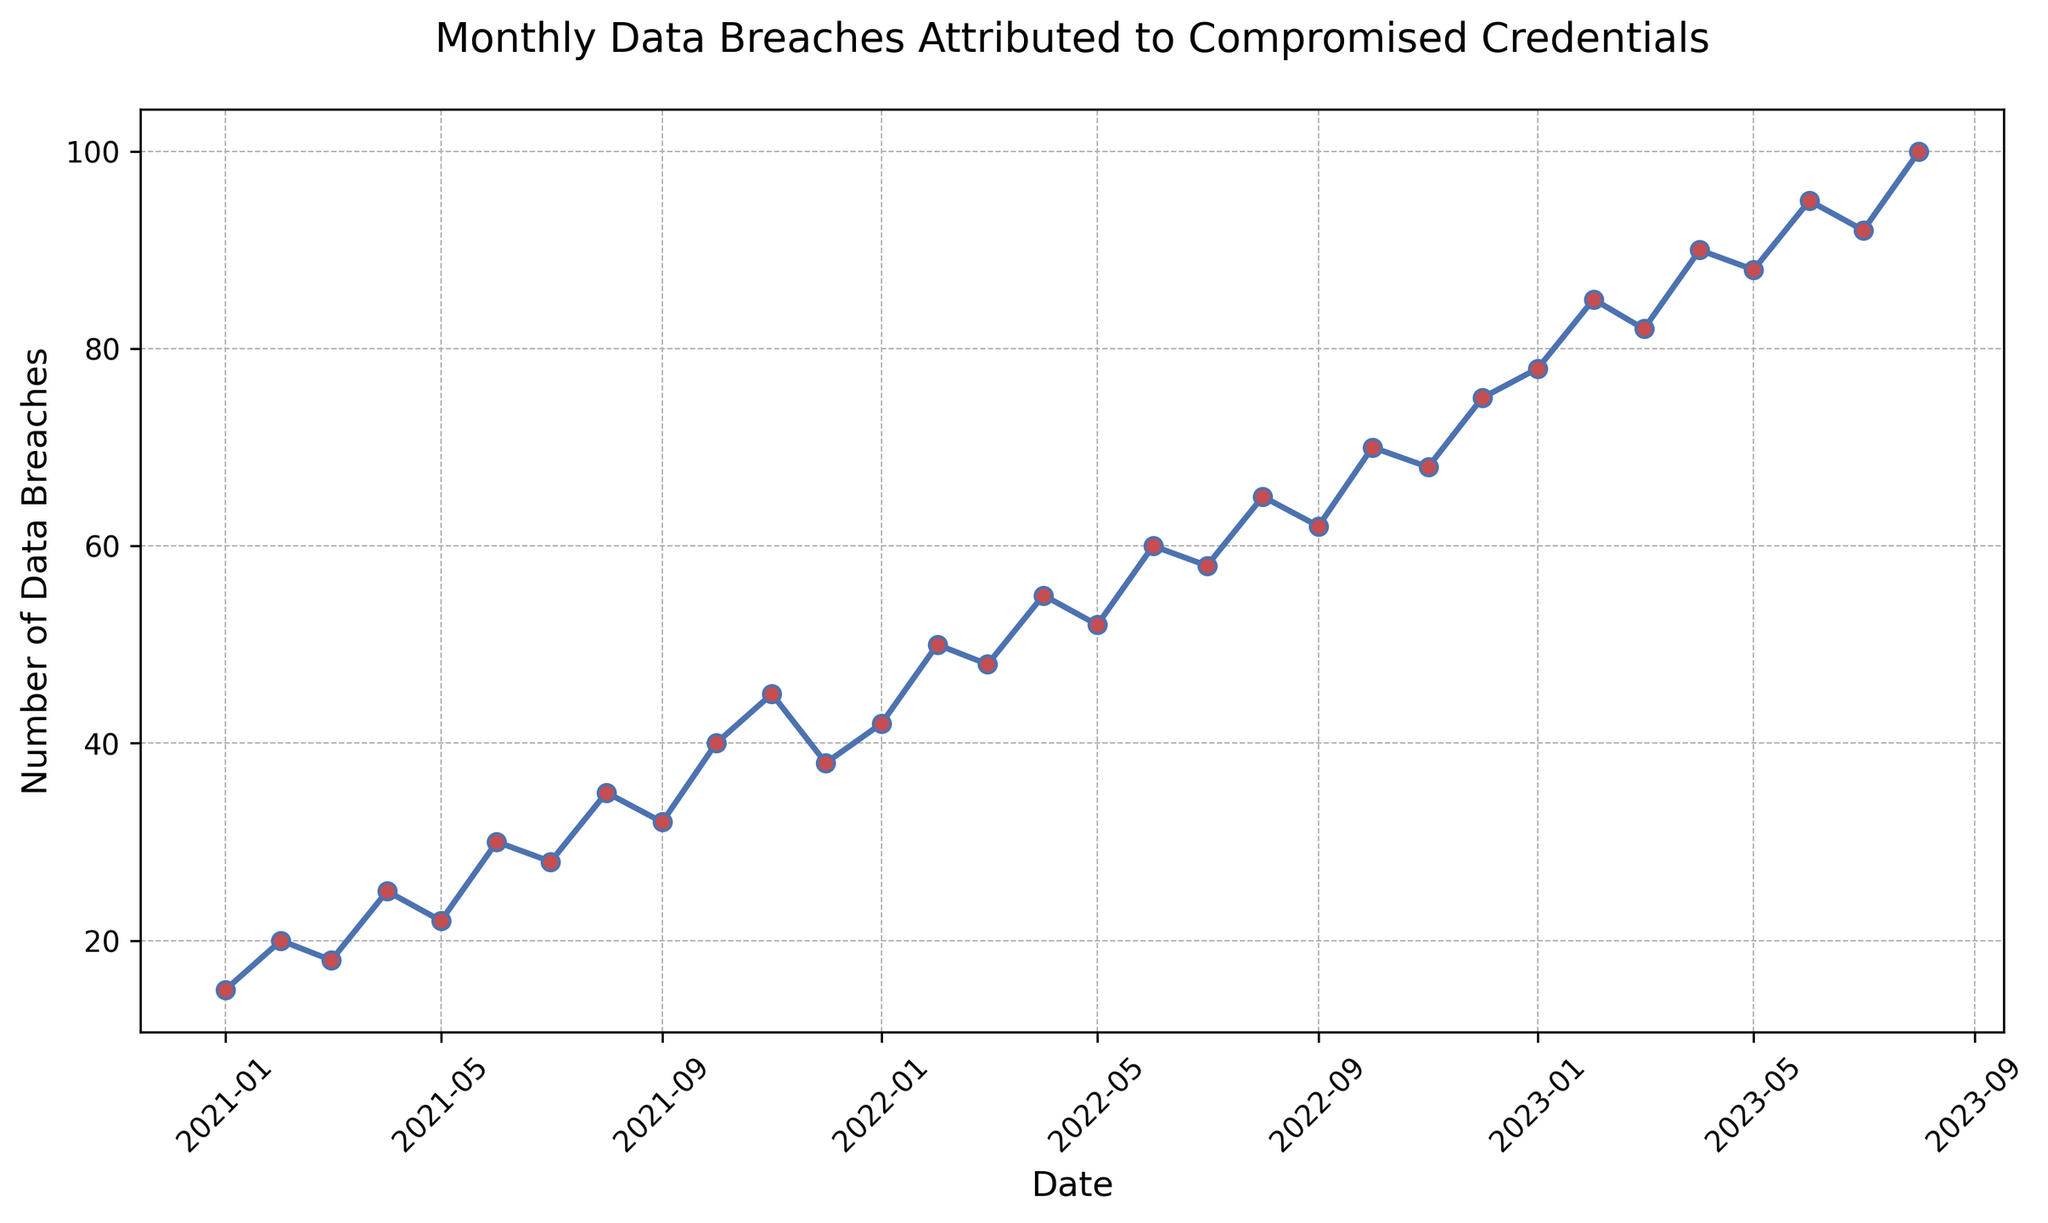What is the highest number of data breaches recorded in a single month? To find the highest number of data breaches recorded in a single month, locate the peak of the line chart. The highest point corresponds to the maximum number of breaches, which occurs in August 2023.
Answer: 100 How did the number of data breaches change from January 2021 to August 2023? Observe the trend line from January 2021 (start) to August 2023 (end). There is a steady increase in the number of data breaches over this period, starting from 15 in January 2021 and reaching 100 by August 2023.
Answer: Steady increase In which month did the data breaches surpass 50 for the first time? To find when the data breaches first surpassed 50, scan the line chart until you find the earliest point where the data breaches exceed 50. This happens in February 2022.
Answer: February 2022 What are the total number of data breaches recorded in the last six months of the dataset (March 2023 to August 2023)? Sum the number of data breaches for the months in question: 82 (March 2023), 90 (April 2023), 88 (May 2023), 95 (June 2023), 92 (July 2023), and 100 (August 2023). The total is 82 + 90 + 88 + 95 + 92 + 100 = 547.
Answer: 547 Compare the number of data breaches in January 2022 and January 2021. How much did it increase by? Find the values for January 2022 and January 2021. January 2021 had 15 breaches, and January 2022 had 42 breaches. The increase is calculated as 42 - 15 = 27.
Answer: 27 How many months show a decrease in the number of data breaches compared to the previous month? Scan the chart for instances where the line goes downward, indicating a decrease from one month to the next. Decreases occur in December 2021, January 2023, and June 2023.
Answer: 3 months What is the average number of data breaches per month over the entire period? Sum all the monthly data breaches from January 2021 to August 2023 and divide by the number of months (32 months). The sum of breaches: 15 + 20 + 18 + 25 + 22 + 30 + 28 + 35 + 32 + 40 + 45 + 38 + 42 + 50 + 48 + 55 + 52 + 60 + 58 + 65 + 62 + 70 + 68 + 75 + 78 + 85 + 82 + 90 + 88 + 95 + 92 + 100 = 1710. Average is 1710 / 32 = 53.4375.
Answer: 53.44 What trend can be observed during October 2022 to January 2023? Observe the line from October 2022 to January 2023. The trend shows an upward climb, indicating an increase in data breaches over these months.
Answer: Increasing trend 